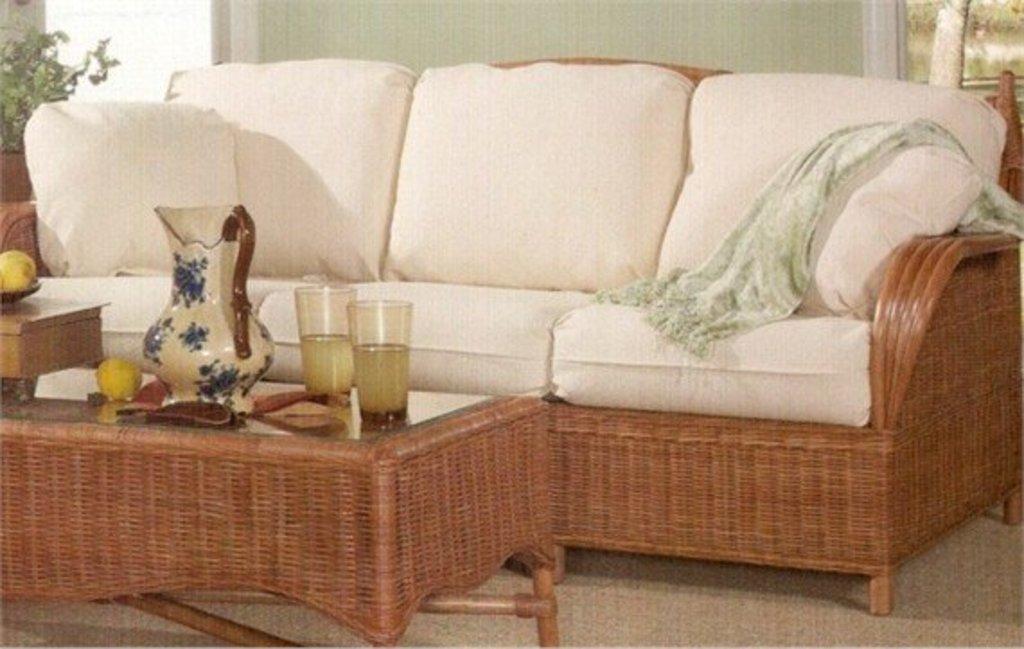Please provide a concise description of this image. In this image we can see a sofa. On the sofa there is a towel, in front of the sofa there is a table. On the table there is a jar, two glasses of juice and some objects. On the left side there is a plant pot. 